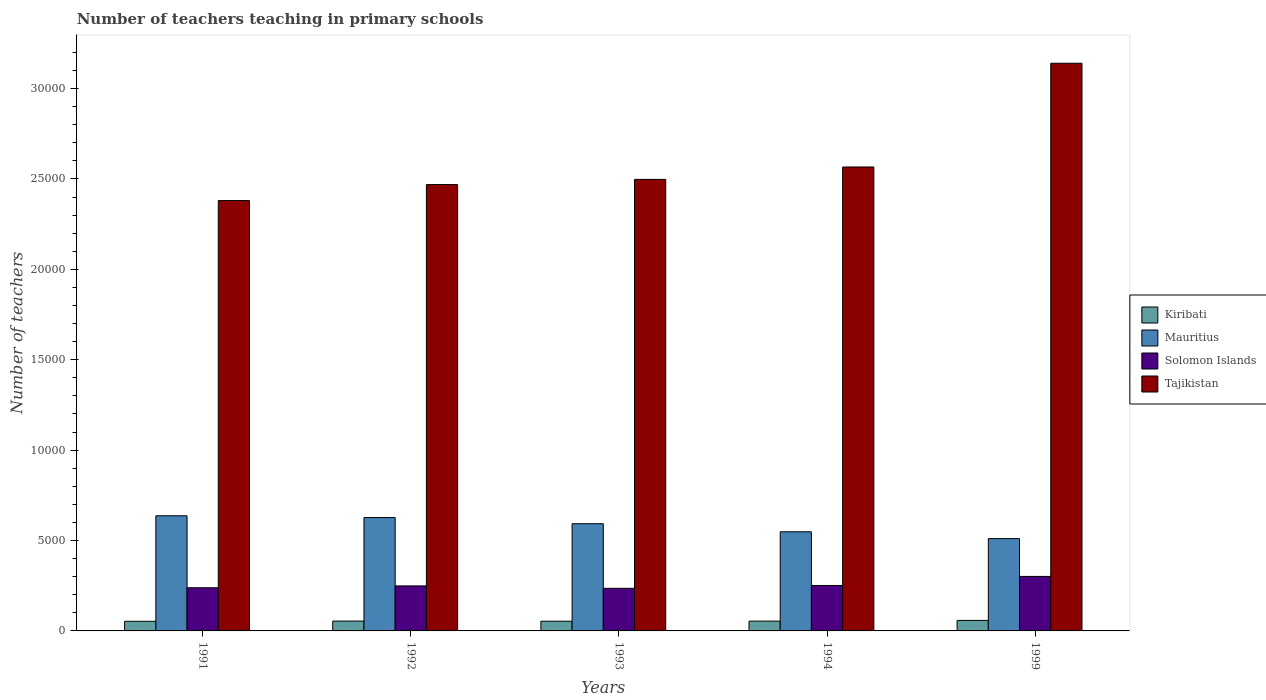How many different coloured bars are there?
Give a very brief answer. 4. How many bars are there on the 2nd tick from the right?
Make the answer very short. 4. In how many cases, is the number of bars for a given year not equal to the number of legend labels?
Provide a succinct answer. 0. What is the number of teachers teaching in primary schools in Mauritius in 1992?
Your answer should be very brief. 6272. Across all years, what is the maximum number of teachers teaching in primary schools in Kiribati?
Your answer should be compact. 581. Across all years, what is the minimum number of teachers teaching in primary schools in Mauritius?
Offer a very short reply. 5107. What is the total number of teachers teaching in primary schools in Kiribati in the graph?
Your response must be concise. 2738. What is the difference between the number of teachers teaching in primary schools in Mauritius in 1993 and that in 1994?
Ensure brevity in your answer.  448. What is the difference between the number of teachers teaching in primary schools in Solomon Islands in 1992 and the number of teachers teaching in primary schools in Kiribati in 1994?
Provide a short and direct response. 1948. What is the average number of teachers teaching in primary schools in Tajikistan per year?
Keep it short and to the point. 2.61e+04. In the year 1992, what is the difference between the number of teachers teaching in primary schools in Kiribati and number of teachers teaching in primary schools in Tajikistan?
Provide a short and direct response. -2.41e+04. In how many years, is the number of teachers teaching in primary schools in Solomon Islands greater than 16000?
Offer a very short reply. 0. What is the ratio of the number of teachers teaching in primary schools in Tajikistan in 1992 to that in 1999?
Offer a terse response. 0.79. Is the difference between the number of teachers teaching in primary schools in Kiribati in 1991 and 1992 greater than the difference between the number of teachers teaching in primary schools in Tajikistan in 1991 and 1992?
Ensure brevity in your answer.  Yes. What is the difference between the highest and the lowest number of teachers teaching in primary schools in Kiribati?
Your answer should be very brief. 48. What does the 3rd bar from the left in 1992 represents?
Ensure brevity in your answer.  Solomon Islands. What does the 4th bar from the right in 1994 represents?
Offer a terse response. Kiribati. Is it the case that in every year, the sum of the number of teachers teaching in primary schools in Tajikistan and number of teachers teaching in primary schools in Mauritius is greater than the number of teachers teaching in primary schools in Kiribati?
Offer a terse response. Yes. Are all the bars in the graph horizontal?
Make the answer very short. No. What is the difference between two consecutive major ticks on the Y-axis?
Offer a very short reply. 5000. Does the graph contain grids?
Give a very brief answer. No. Where does the legend appear in the graph?
Your response must be concise. Center right. How many legend labels are there?
Your answer should be very brief. 4. How are the legend labels stacked?
Your response must be concise. Vertical. What is the title of the graph?
Offer a terse response. Number of teachers teaching in primary schools. What is the label or title of the X-axis?
Provide a succinct answer. Years. What is the label or title of the Y-axis?
Provide a succinct answer. Number of teachers. What is the Number of teachers of Kiribati in 1991?
Offer a very short reply. 533. What is the Number of teachers of Mauritius in 1991?
Your answer should be very brief. 6369. What is the Number of teachers of Solomon Islands in 1991?
Offer a very short reply. 2388. What is the Number of teachers of Tajikistan in 1991?
Make the answer very short. 2.38e+04. What is the Number of teachers of Kiribati in 1992?
Your response must be concise. 545. What is the Number of teachers in Mauritius in 1992?
Provide a short and direct response. 6272. What is the Number of teachers of Solomon Islands in 1992?
Your response must be concise. 2490. What is the Number of teachers of Tajikistan in 1992?
Make the answer very short. 2.47e+04. What is the Number of teachers in Kiribati in 1993?
Your answer should be very brief. 537. What is the Number of teachers of Mauritius in 1993?
Keep it short and to the point. 5931. What is the Number of teachers of Solomon Islands in 1993?
Provide a succinct answer. 2357. What is the Number of teachers of Tajikistan in 1993?
Your response must be concise. 2.50e+04. What is the Number of teachers in Kiribati in 1994?
Provide a short and direct response. 542. What is the Number of teachers of Mauritius in 1994?
Offer a very short reply. 5483. What is the Number of teachers in Solomon Islands in 1994?
Provide a short and direct response. 2514. What is the Number of teachers in Tajikistan in 1994?
Ensure brevity in your answer.  2.57e+04. What is the Number of teachers of Kiribati in 1999?
Offer a terse response. 581. What is the Number of teachers in Mauritius in 1999?
Give a very brief answer. 5107. What is the Number of teachers in Solomon Islands in 1999?
Ensure brevity in your answer.  3014. What is the Number of teachers in Tajikistan in 1999?
Provide a short and direct response. 3.14e+04. Across all years, what is the maximum Number of teachers of Kiribati?
Make the answer very short. 581. Across all years, what is the maximum Number of teachers in Mauritius?
Ensure brevity in your answer.  6369. Across all years, what is the maximum Number of teachers of Solomon Islands?
Your response must be concise. 3014. Across all years, what is the maximum Number of teachers in Tajikistan?
Provide a succinct answer. 3.14e+04. Across all years, what is the minimum Number of teachers of Kiribati?
Your answer should be compact. 533. Across all years, what is the minimum Number of teachers of Mauritius?
Provide a short and direct response. 5107. Across all years, what is the minimum Number of teachers in Solomon Islands?
Keep it short and to the point. 2357. Across all years, what is the minimum Number of teachers of Tajikistan?
Provide a short and direct response. 2.38e+04. What is the total Number of teachers in Kiribati in the graph?
Offer a very short reply. 2738. What is the total Number of teachers in Mauritius in the graph?
Offer a very short reply. 2.92e+04. What is the total Number of teachers in Solomon Islands in the graph?
Offer a terse response. 1.28e+04. What is the total Number of teachers of Tajikistan in the graph?
Ensure brevity in your answer.  1.31e+05. What is the difference between the Number of teachers in Mauritius in 1991 and that in 1992?
Make the answer very short. 97. What is the difference between the Number of teachers of Solomon Islands in 1991 and that in 1992?
Ensure brevity in your answer.  -102. What is the difference between the Number of teachers of Tajikistan in 1991 and that in 1992?
Your response must be concise. -884. What is the difference between the Number of teachers in Kiribati in 1991 and that in 1993?
Provide a short and direct response. -4. What is the difference between the Number of teachers in Mauritius in 1991 and that in 1993?
Provide a short and direct response. 438. What is the difference between the Number of teachers in Solomon Islands in 1991 and that in 1993?
Give a very brief answer. 31. What is the difference between the Number of teachers in Tajikistan in 1991 and that in 1993?
Offer a terse response. -1170. What is the difference between the Number of teachers in Mauritius in 1991 and that in 1994?
Offer a terse response. 886. What is the difference between the Number of teachers in Solomon Islands in 1991 and that in 1994?
Ensure brevity in your answer.  -126. What is the difference between the Number of teachers in Tajikistan in 1991 and that in 1994?
Offer a terse response. -1857. What is the difference between the Number of teachers of Kiribati in 1991 and that in 1999?
Your response must be concise. -48. What is the difference between the Number of teachers in Mauritius in 1991 and that in 1999?
Provide a succinct answer. 1262. What is the difference between the Number of teachers of Solomon Islands in 1991 and that in 1999?
Give a very brief answer. -626. What is the difference between the Number of teachers of Tajikistan in 1991 and that in 1999?
Make the answer very short. -7595. What is the difference between the Number of teachers in Kiribati in 1992 and that in 1993?
Give a very brief answer. 8. What is the difference between the Number of teachers of Mauritius in 1992 and that in 1993?
Your answer should be very brief. 341. What is the difference between the Number of teachers in Solomon Islands in 1992 and that in 1993?
Your answer should be very brief. 133. What is the difference between the Number of teachers of Tajikistan in 1992 and that in 1993?
Give a very brief answer. -286. What is the difference between the Number of teachers of Mauritius in 1992 and that in 1994?
Your answer should be compact. 789. What is the difference between the Number of teachers of Tajikistan in 1992 and that in 1994?
Ensure brevity in your answer.  -973. What is the difference between the Number of teachers in Kiribati in 1992 and that in 1999?
Keep it short and to the point. -36. What is the difference between the Number of teachers of Mauritius in 1992 and that in 1999?
Offer a terse response. 1165. What is the difference between the Number of teachers of Solomon Islands in 1992 and that in 1999?
Offer a very short reply. -524. What is the difference between the Number of teachers in Tajikistan in 1992 and that in 1999?
Offer a very short reply. -6711. What is the difference between the Number of teachers of Kiribati in 1993 and that in 1994?
Your answer should be very brief. -5. What is the difference between the Number of teachers in Mauritius in 1993 and that in 1994?
Ensure brevity in your answer.  448. What is the difference between the Number of teachers of Solomon Islands in 1993 and that in 1994?
Provide a short and direct response. -157. What is the difference between the Number of teachers of Tajikistan in 1993 and that in 1994?
Give a very brief answer. -687. What is the difference between the Number of teachers of Kiribati in 1993 and that in 1999?
Provide a short and direct response. -44. What is the difference between the Number of teachers in Mauritius in 1993 and that in 1999?
Ensure brevity in your answer.  824. What is the difference between the Number of teachers of Solomon Islands in 1993 and that in 1999?
Your answer should be very brief. -657. What is the difference between the Number of teachers in Tajikistan in 1993 and that in 1999?
Give a very brief answer. -6425. What is the difference between the Number of teachers of Kiribati in 1994 and that in 1999?
Ensure brevity in your answer.  -39. What is the difference between the Number of teachers of Mauritius in 1994 and that in 1999?
Offer a terse response. 376. What is the difference between the Number of teachers of Solomon Islands in 1994 and that in 1999?
Your answer should be compact. -500. What is the difference between the Number of teachers in Tajikistan in 1994 and that in 1999?
Provide a succinct answer. -5738. What is the difference between the Number of teachers of Kiribati in 1991 and the Number of teachers of Mauritius in 1992?
Offer a terse response. -5739. What is the difference between the Number of teachers of Kiribati in 1991 and the Number of teachers of Solomon Islands in 1992?
Your answer should be compact. -1957. What is the difference between the Number of teachers of Kiribati in 1991 and the Number of teachers of Tajikistan in 1992?
Ensure brevity in your answer.  -2.42e+04. What is the difference between the Number of teachers in Mauritius in 1991 and the Number of teachers in Solomon Islands in 1992?
Offer a very short reply. 3879. What is the difference between the Number of teachers in Mauritius in 1991 and the Number of teachers in Tajikistan in 1992?
Make the answer very short. -1.83e+04. What is the difference between the Number of teachers of Solomon Islands in 1991 and the Number of teachers of Tajikistan in 1992?
Offer a terse response. -2.23e+04. What is the difference between the Number of teachers of Kiribati in 1991 and the Number of teachers of Mauritius in 1993?
Provide a succinct answer. -5398. What is the difference between the Number of teachers of Kiribati in 1991 and the Number of teachers of Solomon Islands in 1993?
Offer a terse response. -1824. What is the difference between the Number of teachers in Kiribati in 1991 and the Number of teachers in Tajikistan in 1993?
Your answer should be very brief. -2.44e+04. What is the difference between the Number of teachers in Mauritius in 1991 and the Number of teachers in Solomon Islands in 1993?
Your answer should be compact. 4012. What is the difference between the Number of teachers of Mauritius in 1991 and the Number of teachers of Tajikistan in 1993?
Keep it short and to the point. -1.86e+04. What is the difference between the Number of teachers in Solomon Islands in 1991 and the Number of teachers in Tajikistan in 1993?
Offer a terse response. -2.26e+04. What is the difference between the Number of teachers in Kiribati in 1991 and the Number of teachers in Mauritius in 1994?
Make the answer very short. -4950. What is the difference between the Number of teachers in Kiribati in 1991 and the Number of teachers in Solomon Islands in 1994?
Your answer should be compact. -1981. What is the difference between the Number of teachers of Kiribati in 1991 and the Number of teachers of Tajikistan in 1994?
Your response must be concise. -2.51e+04. What is the difference between the Number of teachers in Mauritius in 1991 and the Number of teachers in Solomon Islands in 1994?
Offer a terse response. 3855. What is the difference between the Number of teachers of Mauritius in 1991 and the Number of teachers of Tajikistan in 1994?
Keep it short and to the point. -1.93e+04. What is the difference between the Number of teachers of Solomon Islands in 1991 and the Number of teachers of Tajikistan in 1994?
Offer a terse response. -2.33e+04. What is the difference between the Number of teachers of Kiribati in 1991 and the Number of teachers of Mauritius in 1999?
Make the answer very short. -4574. What is the difference between the Number of teachers of Kiribati in 1991 and the Number of teachers of Solomon Islands in 1999?
Make the answer very short. -2481. What is the difference between the Number of teachers in Kiribati in 1991 and the Number of teachers in Tajikistan in 1999?
Your answer should be compact. -3.09e+04. What is the difference between the Number of teachers of Mauritius in 1991 and the Number of teachers of Solomon Islands in 1999?
Offer a terse response. 3355. What is the difference between the Number of teachers in Mauritius in 1991 and the Number of teachers in Tajikistan in 1999?
Ensure brevity in your answer.  -2.50e+04. What is the difference between the Number of teachers of Solomon Islands in 1991 and the Number of teachers of Tajikistan in 1999?
Ensure brevity in your answer.  -2.90e+04. What is the difference between the Number of teachers in Kiribati in 1992 and the Number of teachers in Mauritius in 1993?
Offer a very short reply. -5386. What is the difference between the Number of teachers in Kiribati in 1992 and the Number of teachers in Solomon Islands in 1993?
Give a very brief answer. -1812. What is the difference between the Number of teachers of Kiribati in 1992 and the Number of teachers of Tajikistan in 1993?
Provide a succinct answer. -2.44e+04. What is the difference between the Number of teachers in Mauritius in 1992 and the Number of teachers in Solomon Islands in 1993?
Your answer should be compact. 3915. What is the difference between the Number of teachers of Mauritius in 1992 and the Number of teachers of Tajikistan in 1993?
Ensure brevity in your answer.  -1.87e+04. What is the difference between the Number of teachers in Solomon Islands in 1992 and the Number of teachers in Tajikistan in 1993?
Provide a short and direct response. -2.25e+04. What is the difference between the Number of teachers in Kiribati in 1992 and the Number of teachers in Mauritius in 1994?
Make the answer very short. -4938. What is the difference between the Number of teachers in Kiribati in 1992 and the Number of teachers in Solomon Islands in 1994?
Provide a succinct answer. -1969. What is the difference between the Number of teachers in Kiribati in 1992 and the Number of teachers in Tajikistan in 1994?
Offer a very short reply. -2.51e+04. What is the difference between the Number of teachers in Mauritius in 1992 and the Number of teachers in Solomon Islands in 1994?
Make the answer very short. 3758. What is the difference between the Number of teachers of Mauritius in 1992 and the Number of teachers of Tajikistan in 1994?
Ensure brevity in your answer.  -1.94e+04. What is the difference between the Number of teachers of Solomon Islands in 1992 and the Number of teachers of Tajikistan in 1994?
Make the answer very short. -2.32e+04. What is the difference between the Number of teachers in Kiribati in 1992 and the Number of teachers in Mauritius in 1999?
Provide a short and direct response. -4562. What is the difference between the Number of teachers in Kiribati in 1992 and the Number of teachers in Solomon Islands in 1999?
Keep it short and to the point. -2469. What is the difference between the Number of teachers of Kiribati in 1992 and the Number of teachers of Tajikistan in 1999?
Your response must be concise. -3.09e+04. What is the difference between the Number of teachers in Mauritius in 1992 and the Number of teachers in Solomon Islands in 1999?
Make the answer very short. 3258. What is the difference between the Number of teachers of Mauritius in 1992 and the Number of teachers of Tajikistan in 1999?
Provide a short and direct response. -2.51e+04. What is the difference between the Number of teachers in Solomon Islands in 1992 and the Number of teachers in Tajikistan in 1999?
Ensure brevity in your answer.  -2.89e+04. What is the difference between the Number of teachers of Kiribati in 1993 and the Number of teachers of Mauritius in 1994?
Provide a succinct answer. -4946. What is the difference between the Number of teachers in Kiribati in 1993 and the Number of teachers in Solomon Islands in 1994?
Make the answer very short. -1977. What is the difference between the Number of teachers in Kiribati in 1993 and the Number of teachers in Tajikistan in 1994?
Your answer should be very brief. -2.51e+04. What is the difference between the Number of teachers in Mauritius in 1993 and the Number of teachers in Solomon Islands in 1994?
Ensure brevity in your answer.  3417. What is the difference between the Number of teachers in Mauritius in 1993 and the Number of teachers in Tajikistan in 1994?
Your answer should be compact. -1.97e+04. What is the difference between the Number of teachers in Solomon Islands in 1993 and the Number of teachers in Tajikistan in 1994?
Your answer should be very brief. -2.33e+04. What is the difference between the Number of teachers of Kiribati in 1993 and the Number of teachers of Mauritius in 1999?
Keep it short and to the point. -4570. What is the difference between the Number of teachers in Kiribati in 1993 and the Number of teachers in Solomon Islands in 1999?
Give a very brief answer. -2477. What is the difference between the Number of teachers of Kiribati in 1993 and the Number of teachers of Tajikistan in 1999?
Your response must be concise. -3.09e+04. What is the difference between the Number of teachers of Mauritius in 1993 and the Number of teachers of Solomon Islands in 1999?
Ensure brevity in your answer.  2917. What is the difference between the Number of teachers of Mauritius in 1993 and the Number of teachers of Tajikistan in 1999?
Keep it short and to the point. -2.55e+04. What is the difference between the Number of teachers of Solomon Islands in 1993 and the Number of teachers of Tajikistan in 1999?
Your response must be concise. -2.90e+04. What is the difference between the Number of teachers of Kiribati in 1994 and the Number of teachers of Mauritius in 1999?
Offer a very short reply. -4565. What is the difference between the Number of teachers in Kiribati in 1994 and the Number of teachers in Solomon Islands in 1999?
Ensure brevity in your answer.  -2472. What is the difference between the Number of teachers of Kiribati in 1994 and the Number of teachers of Tajikistan in 1999?
Provide a short and direct response. -3.09e+04. What is the difference between the Number of teachers of Mauritius in 1994 and the Number of teachers of Solomon Islands in 1999?
Your answer should be very brief. 2469. What is the difference between the Number of teachers of Mauritius in 1994 and the Number of teachers of Tajikistan in 1999?
Give a very brief answer. -2.59e+04. What is the difference between the Number of teachers in Solomon Islands in 1994 and the Number of teachers in Tajikistan in 1999?
Provide a succinct answer. -2.89e+04. What is the average Number of teachers of Kiribati per year?
Your response must be concise. 547.6. What is the average Number of teachers of Mauritius per year?
Give a very brief answer. 5832.4. What is the average Number of teachers of Solomon Islands per year?
Your response must be concise. 2552.6. What is the average Number of teachers in Tajikistan per year?
Your answer should be very brief. 2.61e+04. In the year 1991, what is the difference between the Number of teachers of Kiribati and Number of teachers of Mauritius?
Offer a very short reply. -5836. In the year 1991, what is the difference between the Number of teachers in Kiribati and Number of teachers in Solomon Islands?
Your response must be concise. -1855. In the year 1991, what is the difference between the Number of teachers in Kiribati and Number of teachers in Tajikistan?
Your answer should be compact. -2.33e+04. In the year 1991, what is the difference between the Number of teachers of Mauritius and Number of teachers of Solomon Islands?
Your answer should be compact. 3981. In the year 1991, what is the difference between the Number of teachers in Mauritius and Number of teachers in Tajikistan?
Offer a very short reply. -1.74e+04. In the year 1991, what is the difference between the Number of teachers of Solomon Islands and Number of teachers of Tajikistan?
Keep it short and to the point. -2.14e+04. In the year 1992, what is the difference between the Number of teachers of Kiribati and Number of teachers of Mauritius?
Your answer should be very brief. -5727. In the year 1992, what is the difference between the Number of teachers of Kiribati and Number of teachers of Solomon Islands?
Keep it short and to the point. -1945. In the year 1992, what is the difference between the Number of teachers of Kiribati and Number of teachers of Tajikistan?
Give a very brief answer. -2.41e+04. In the year 1992, what is the difference between the Number of teachers in Mauritius and Number of teachers in Solomon Islands?
Offer a very short reply. 3782. In the year 1992, what is the difference between the Number of teachers in Mauritius and Number of teachers in Tajikistan?
Your answer should be compact. -1.84e+04. In the year 1992, what is the difference between the Number of teachers of Solomon Islands and Number of teachers of Tajikistan?
Give a very brief answer. -2.22e+04. In the year 1993, what is the difference between the Number of teachers in Kiribati and Number of teachers in Mauritius?
Your answer should be very brief. -5394. In the year 1993, what is the difference between the Number of teachers of Kiribati and Number of teachers of Solomon Islands?
Make the answer very short. -1820. In the year 1993, what is the difference between the Number of teachers of Kiribati and Number of teachers of Tajikistan?
Give a very brief answer. -2.44e+04. In the year 1993, what is the difference between the Number of teachers in Mauritius and Number of teachers in Solomon Islands?
Provide a short and direct response. 3574. In the year 1993, what is the difference between the Number of teachers in Mauritius and Number of teachers in Tajikistan?
Your answer should be very brief. -1.90e+04. In the year 1993, what is the difference between the Number of teachers in Solomon Islands and Number of teachers in Tajikistan?
Offer a terse response. -2.26e+04. In the year 1994, what is the difference between the Number of teachers in Kiribati and Number of teachers in Mauritius?
Make the answer very short. -4941. In the year 1994, what is the difference between the Number of teachers in Kiribati and Number of teachers in Solomon Islands?
Your answer should be very brief. -1972. In the year 1994, what is the difference between the Number of teachers in Kiribati and Number of teachers in Tajikistan?
Offer a terse response. -2.51e+04. In the year 1994, what is the difference between the Number of teachers in Mauritius and Number of teachers in Solomon Islands?
Your response must be concise. 2969. In the year 1994, what is the difference between the Number of teachers in Mauritius and Number of teachers in Tajikistan?
Offer a terse response. -2.02e+04. In the year 1994, what is the difference between the Number of teachers in Solomon Islands and Number of teachers in Tajikistan?
Ensure brevity in your answer.  -2.32e+04. In the year 1999, what is the difference between the Number of teachers of Kiribati and Number of teachers of Mauritius?
Provide a short and direct response. -4526. In the year 1999, what is the difference between the Number of teachers in Kiribati and Number of teachers in Solomon Islands?
Provide a succinct answer. -2433. In the year 1999, what is the difference between the Number of teachers of Kiribati and Number of teachers of Tajikistan?
Ensure brevity in your answer.  -3.08e+04. In the year 1999, what is the difference between the Number of teachers in Mauritius and Number of teachers in Solomon Islands?
Your response must be concise. 2093. In the year 1999, what is the difference between the Number of teachers of Mauritius and Number of teachers of Tajikistan?
Provide a short and direct response. -2.63e+04. In the year 1999, what is the difference between the Number of teachers of Solomon Islands and Number of teachers of Tajikistan?
Give a very brief answer. -2.84e+04. What is the ratio of the Number of teachers in Kiribati in 1991 to that in 1992?
Your answer should be compact. 0.98. What is the ratio of the Number of teachers of Mauritius in 1991 to that in 1992?
Your answer should be compact. 1.02. What is the ratio of the Number of teachers of Solomon Islands in 1991 to that in 1992?
Ensure brevity in your answer.  0.96. What is the ratio of the Number of teachers in Tajikistan in 1991 to that in 1992?
Offer a terse response. 0.96. What is the ratio of the Number of teachers of Mauritius in 1991 to that in 1993?
Offer a terse response. 1.07. What is the ratio of the Number of teachers of Solomon Islands in 1991 to that in 1993?
Provide a succinct answer. 1.01. What is the ratio of the Number of teachers of Tajikistan in 1991 to that in 1993?
Keep it short and to the point. 0.95. What is the ratio of the Number of teachers in Kiribati in 1991 to that in 1994?
Your answer should be very brief. 0.98. What is the ratio of the Number of teachers of Mauritius in 1991 to that in 1994?
Keep it short and to the point. 1.16. What is the ratio of the Number of teachers of Solomon Islands in 1991 to that in 1994?
Ensure brevity in your answer.  0.95. What is the ratio of the Number of teachers of Tajikistan in 1991 to that in 1994?
Make the answer very short. 0.93. What is the ratio of the Number of teachers of Kiribati in 1991 to that in 1999?
Your answer should be compact. 0.92. What is the ratio of the Number of teachers of Mauritius in 1991 to that in 1999?
Your answer should be compact. 1.25. What is the ratio of the Number of teachers in Solomon Islands in 1991 to that in 1999?
Make the answer very short. 0.79. What is the ratio of the Number of teachers of Tajikistan in 1991 to that in 1999?
Your answer should be very brief. 0.76. What is the ratio of the Number of teachers of Kiribati in 1992 to that in 1993?
Your response must be concise. 1.01. What is the ratio of the Number of teachers of Mauritius in 1992 to that in 1993?
Provide a short and direct response. 1.06. What is the ratio of the Number of teachers of Solomon Islands in 1992 to that in 1993?
Make the answer very short. 1.06. What is the ratio of the Number of teachers in Mauritius in 1992 to that in 1994?
Your answer should be compact. 1.14. What is the ratio of the Number of teachers of Tajikistan in 1992 to that in 1994?
Provide a short and direct response. 0.96. What is the ratio of the Number of teachers of Kiribati in 1992 to that in 1999?
Your answer should be very brief. 0.94. What is the ratio of the Number of teachers of Mauritius in 1992 to that in 1999?
Offer a very short reply. 1.23. What is the ratio of the Number of teachers in Solomon Islands in 1992 to that in 1999?
Keep it short and to the point. 0.83. What is the ratio of the Number of teachers of Tajikistan in 1992 to that in 1999?
Offer a terse response. 0.79. What is the ratio of the Number of teachers of Mauritius in 1993 to that in 1994?
Your response must be concise. 1.08. What is the ratio of the Number of teachers of Tajikistan in 1993 to that in 1994?
Provide a succinct answer. 0.97. What is the ratio of the Number of teachers in Kiribati in 1993 to that in 1999?
Your answer should be compact. 0.92. What is the ratio of the Number of teachers of Mauritius in 1993 to that in 1999?
Provide a succinct answer. 1.16. What is the ratio of the Number of teachers in Solomon Islands in 1993 to that in 1999?
Your response must be concise. 0.78. What is the ratio of the Number of teachers of Tajikistan in 1993 to that in 1999?
Keep it short and to the point. 0.8. What is the ratio of the Number of teachers in Kiribati in 1994 to that in 1999?
Provide a succinct answer. 0.93. What is the ratio of the Number of teachers in Mauritius in 1994 to that in 1999?
Your response must be concise. 1.07. What is the ratio of the Number of teachers of Solomon Islands in 1994 to that in 1999?
Your answer should be very brief. 0.83. What is the ratio of the Number of teachers of Tajikistan in 1994 to that in 1999?
Your response must be concise. 0.82. What is the difference between the highest and the second highest Number of teachers of Mauritius?
Your answer should be compact. 97. What is the difference between the highest and the second highest Number of teachers in Tajikistan?
Offer a very short reply. 5738. What is the difference between the highest and the lowest Number of teachers of Kiribati?
Ensure brevity in your answer.  48. What is the difference between the highest and the lowest Number of teachers of Mauritius?
Your response must be concise. 1262. What is the difference between the highest and the lowest Number of teachers of Solomon Islands?
Provide a succinct answer. 657. What is the difference between the highest and the lowest Number of teachers of Tajikistan?
Provide a short and direct response. 7595. 